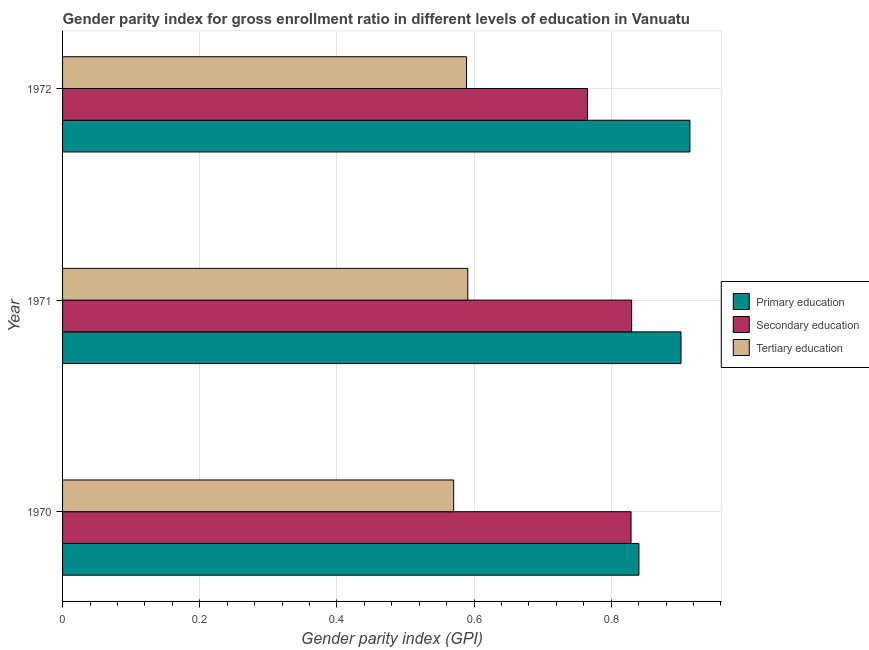How many different coloured bars are there?
Your response must be concise. 3. Are the number of bars per tick equal to the number of legend labels?
Make the answer very short. Yes. Are the number of bars on each tick of the Y-axis equal?
Your answer should be very brief. Yes. What is the label of the 2nd group of bars from the top?
Offer a terse response. 1971. What is the gender parity index in tertiary education in 1971?
Your answer should be compact. 0.59. Across all years, what is the maximum gender parity index in secondary education?
Make the answer very short. 0.83. Across all years, what is the minimum gender parity index in secondary education?
Provide a succinct answer. 0.77. In which year was the gender parity index in primary education maximum?
Your response must be concise. 1972. In which year was the gender parity index in tertiary education minimum?
Your answer should be compact. 1970. What is the total gender parity index in primary education in the graph?
Ensure brevity in your answer.  2.66. What is the difference between the gender parity index in tertiary education in 1970 and that in 1972?
Provide a succinct answer. -0.02. What is the difference between the gender parity index in primary education in 1970 and the gender parity index in secondary education in 1971?
Offer a terse response. 0.01. What is the average gender parity index in tertiary education per year?
Your answer should be very brief. 0.58. In the year 1972, what is the difference between the gender parity index in tertiary education and gender parity index in primary education?
Your answer should be compact. -0.33. What is the difference between the highest and the second highest gender parity index in tertiary education?
Ensure brevity in your answer.  0. Is the sum of the gender parity index in tertiary education in 1971 and 1972 greater than the maximum gender parity index in secondary education across all years?
Ensure brevity in your answer.  Yes. What does the 1st bar from the top in 1970 represents?
Your response must be concise. Tertiary education. What does the 2nd bar from the bottom in 1970 represents?
Provide a short and direct response. Secondary education. Are all the bars in the graph horizontal?
Your answer should be compact. Yes. What is the difference between two consecutive major ticks on the X-axis?
Offer a very short reply. 0.2. Does the graph contain any zero values?
Offer a very short reply. No. Does the graph contain grids?
Ensure brevity in your answer.  Yes. Where does the legend appear in the graph?
Your response must be concise. Center right. What is the title of the graph?
Your response must be concise. Gender parity index for gross enrollment ratio in different levels of education in Vanuatu. What is the label or title of the X-axis?
Make the answer very short. Gender parity index (GPI). What is the label or title of the Y-axis?
Your answer should be compact. Year. What is the Gender parity index (GPI) in Primary education in 1970?
Make the answer very short. 0.84. What is the Gender parity index (GPI) of Secondary education in 1970?
Your response must be concise. 0.83. What is the Gender parity index (GPI) of Tertiary education in 1970?
Keep it short and to the point. 0.57. What is the Gender parity index (GPI) of Primary education in 1971?
Provide a short and direct response. 0.9. What is the Gender parity index (GPI) in Secondary education in 1971?
Offer a terse response. 0.83. What is the Gender parity index (GPI) of Tertiary education in 1971?
Your response must be concise. 0.59. What is the Gender parity index (GPI) of Primary education in 1972?
Your answer should be very brief. 0.91. What is the Gender parity index (GPI) of Secondary education in 1972?
Provide a short and direct response. 0.77. What is the Gender parity index (GPI) in Tertiary education in 1972?
Make the answer very short. 0.59. Across all years, what is the maximum Gender parity index (GPI) in Primary education?
Offer a very short reply. 0.91. Across all years, what is the maximum Gender parity index (GPI) in Secondary education?
Your answer should be very brief. 0.83. Across all years, what is the maximum Gender parity index (GPI) in Tertiary education?
Provide a short and direct response. 0.59. Across all years, what is the minimum Gender parity index (GPI) in Primary education?
Your answer should be very brief. 0.84. Across all years, what is the minimum Gender parity index (GPI) of Secondary education?
Make the answer very short. 0.77. Across all years, what is the minimum Gender parity index (GPI) in Tertiary education?
Give a very brief answer. 0.57. What is the total Gender parity index (GPI) in Primary education in the graph?
Provide a short and direct response. 2.66. What is the total Gender parity index (GPI) of Secondary education in the graph?
Keep it short and to the point. 2.42. What is the total Gender parity index (GPI) in Tertiary education in the graph?
Keep it short and to the point. 1.75. What is the difference between the Gender parity index (GPI) of Primary education in 1970 and that in 1971?
Offer a terse response. -0.06. What is the difference between the Gender parity index (GPI) in Secondary education in 1970 and that in 1971?
Keep it short and to the point. -0. What is the difference between the Gender parity index (GPI) in Tertiary education in 1970 and that in 1971?
Your response must be concise. -0.02. What is the difference between the Gender parity index (GPI) in Primary education in 1970 and that in 1972?
Make the answer very short. -0.07. What is the difference between the Gender parity index (GPI) in Secondary education in 1970 and that in 1972?
Give a very brief answer. 0.06. What is the difference between the Gender parity index (GPI) in Tertiary education in 1970 and that in 1972?
Keep it short and to the point. -0.02. What is the difference between the Gender parity index (GPI) of Primary education in 1971 and that in 1972?
Make the answer very short. -0.01. What is the difference between the Gender parity index (GPI) in Secondary education in 1971 and that in 1972?
Ensure brevity in your answer.  0.06. What is the difference between the Gender parity index (GPI) of Tertiary education in 1971 and that in 1972?
Offer a terse response. 0. What is the difference between the Gender parity index (GPI) in Primary education in 1970 and the Gender parity index (GPI) in Secondary education in 1971?
Keep it short and to the point. 0.01. What is the difference between the Gender parity index (GPI) of Primary education in 1970 and the Gender parity index (GPI) of Tertiary education in 1971?
Provide a succinct answer. 0.25. What is the difference between the Gender parity index (GPI) in Secondary education in 1970 and the Gender parity index (GPI) in Tertiary education in 1971?
Your answer should be compact. 0.24. What is the difference between the Gender parity index (GPI) of Primary education in 1970 and the Gender parity index (GPI) of Secondary education in 1972?
Keep it short and to the point. 0.08. What is the difference between the Gender parity index (GPI) in Primary education in 1970 and the Gender parity index (GPI) in Tertiary education in 1972?
Provide a short and direct response. 0.25. What is the difference between the Gender parity index (GPI) of Secondary education in 1970 and the Gender parity index (GPI) of Tertiary education in 1972?
Your response must be concise. 0.24. What is the difference between the Gender parity index (GPI) in Primary education in 1971 and the Gender parity index (GPI) in Secondary education in 1972?
Your answer should be compact. 0.14. What is the difference between the Gender parity index (GPI) in Primary education in 1971 and the Gender parity index (GPI) in Tertiary education in 1972?
Offer a very short reply. 0.31. What is the difference between the Gender parity index (GPI) of Secondary education in 1971 and the Gender parity index (GPI) of Tertiary education in 1972?
Your answer should be very brief. 0.24. What is the average Gender parity index (GPI) in Primary education per year?
Provide a short and direct response. 0.89. What is the average Gender parity index (GPI) of Secondary education per year?
Give a very brief answer. 0.81. What is the average Gender parity index (GPI) in Tertiary education per year?
Provide a short and direct response. 0.58. In the year 1970, what is the difference between the Gender parity index (GPI) in Primary education and Gender parity index (GPI) in Secondary education?
Keep it short and to the point. 0.01. In the year 1970, what is the difference between the Gender parity index (GPI) in Primary education and Gender parity index (GPI) in Tertiary education?
Your answer should be compact. 0.27. In the year 1970, what is the difference between the Gender parity index (GPI) of Secondary education and Gender parity index (GPI) of Tertiary education?
Offer a very short reply. 0.26. In the year 1971, what is the difference between the Gender parity index (GPI) in Primary education and Gender parity index (GPI) in Secondary education?
Offer a terse response. 0.07. In the year 1971, what is the difference between the Gender parity index (GPI) of Primary education and Gender parity index (GPI) of Tertiary education?
Make the answer very short. 0.31. In the year 1971, what is the difference between the Gender parity index (GPI) of Secondary education and Gender parity index (GPI) of Tertiary education?
Offer a terse response. 0.24. In the year 1972, what is the difference between the Gender parity index (GPI) of Primary education and Gender parity index (GPI) of Secondary education?
Offer a terse response. 0.15. In the year 1972, what is the difference between the Gender parity index (GPI) of Primary education and Gender parity index (GPI) of Tertiary education?
Your answer should be very brief. 0.33. In the year 1972, what is the difference between the Gender parity index (GPI) in Secondary education and Gender parity index (GPI) in Tertiary education?
Provide a short and direct response. 0.18. What is the ratio of the Gender parity index (GPI) in Primary education in 1970 to that in 1971?
Your answer should be compact. 0.93. What is the ratio of the Gender parity index (GPI) in Secondary education in 1970 to that in 1971?
Provide a short and direct response. 1. What is the ratio of the Gender parity index (GPI) in Tertiary education in 1970 to that in 1971?
Provide a short and direct response. 0.97. What is the ratio of the Gender parity index (GPI) of Primary education in 1970 to that in 1972?
Your answer should be compact. 0.92. What is the ratio of the Gender parity index (GPI) of Secondary education in 1970 to that in 1972?
Ensure brevity in your answer.  1.08. What is the ratio of the Gender parity index (GPI) in Tertiary education in 1970 to that in 1972?
Your answer should be very brief. 0.97. What is the ratio of the Gender parity index (GPI) of Primary education in 1971 to that in 1972?
Give a very brief answer. 0.99. What is the ratio of the Gender parity index (GPI) in Secondary education in 1971 to that in 1972?
Offer a very short reply. 1.08. What is the difference between the highest and the second highest Gender parity index (GPI) of Primary education?
Provide a succinct answer. 0.01. What is the difference between the highest and the second highest Gender parity index (GPI) of Secondary education?
Provide a succinct answer. 0. What is the difference between the highest and the second highest Gender parity index (GPI) of Tertiary education?
Your answer should be very brief. 0. What is the difference between the highest and the lowest Gender parity index (GPI) in Primary education?
Your response must be concise. 0.07. What is the difference between the highest and the lowest Gender parity index (GPI) of Secondary education?
Ensure brevity in your answer.  0.06. What is the difference between the highest and the lowest Gender parity index (GPI) in Tertiary education?
Your answer should be compact. 0.02. 